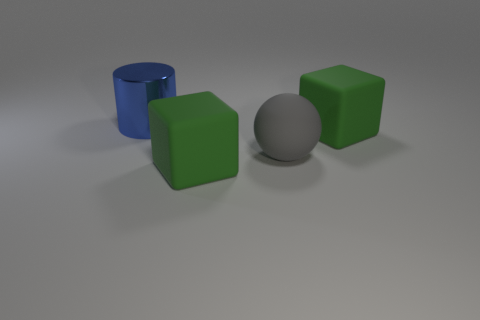Add 4 gray rubber spheres. How many objects exist? 8 Subtract all cylinders. How many objects are left? 3 Subtract all large green shiny objects. Subtract all large gray rubber things. How many objects are left? 3 Add 3 cylinders. How many cylinders are left? 4 Add 1 green rubber cubes. How many green rubber cubes exist? 3 Subtract 1 blue cylinders. How many objects are left? 3 